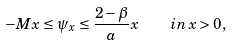Convert formula to latex. <formula><loc_0><loc_0><loc_500><loc_500>- M x \leq \psi _ { x } \leq \frac { 2 - \beta } { a } x \quad i n \, x > 0 ,</formula> 